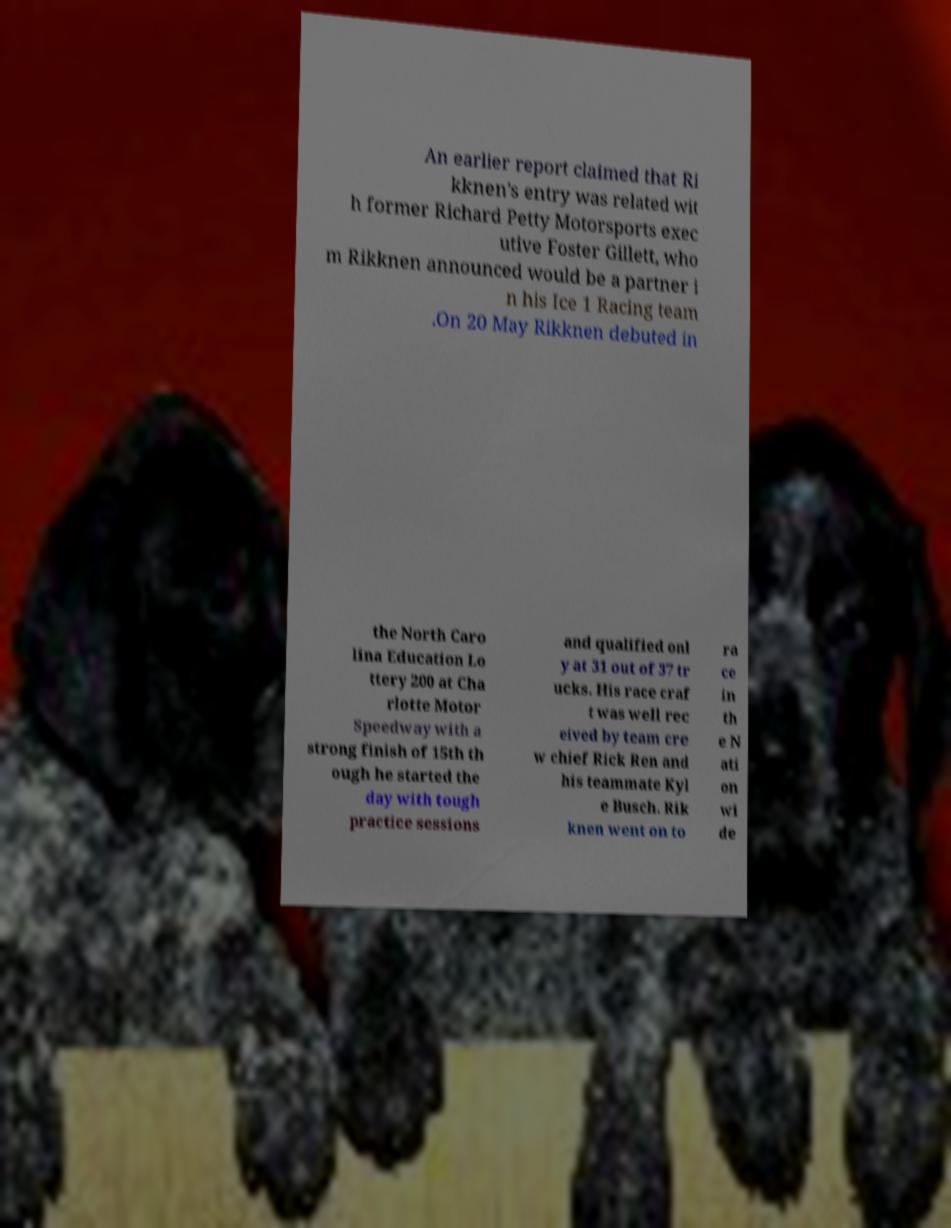Please identify and transcribe the text found in this image. An earlier report claimed that Ri kknen's entry was related wit h former Richard Petty Motorsports exec utive Foster Gillett, who m Rikknen announced would be a partner i n his Ice 1 Racing team .On 20 May Rikknen debuted in the North Caro lina Education Lo ttery 200 at Cha rlotte Motor Speedway with a strong finish of 15th th ough he started the day with tough practice sessions and qualified onl y at 31 out of 37 tr ucks. His race craf t was well rec eived by team cre w chief Rick Ren and his teammate Kyl e Busch. Rik knen went on to ra ce in th e N ati on wi de 